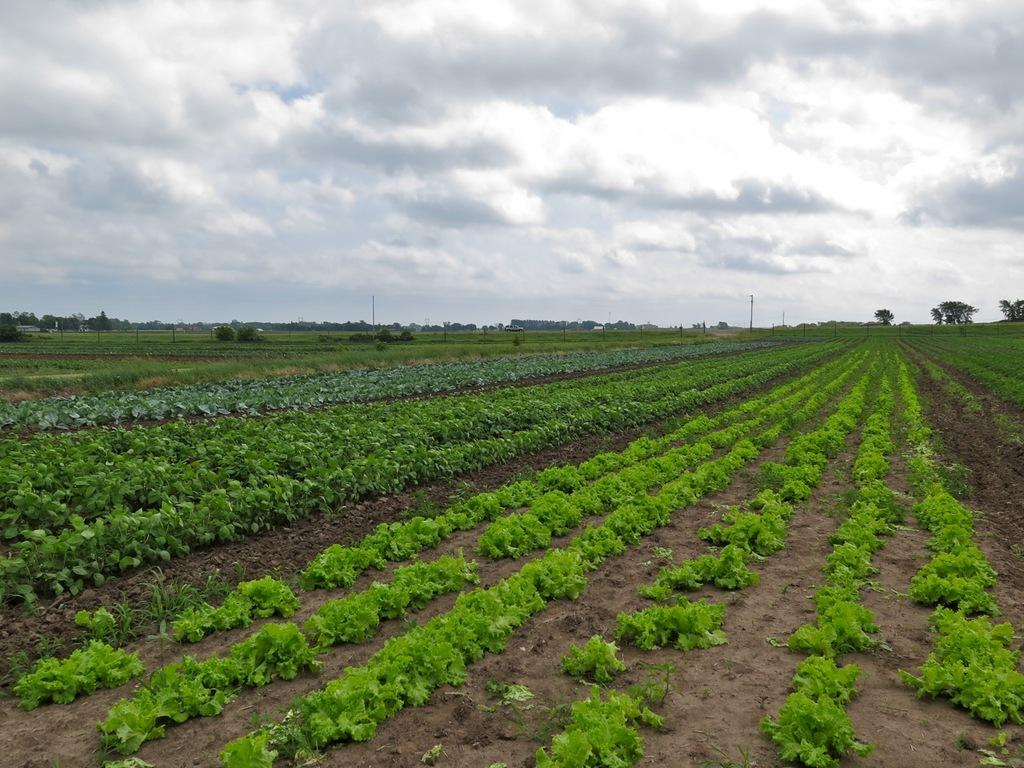What is the main subject in the foreground of the picture? There is a field in the foreground of the picture. What can be found in the field? The field contains plants and soil. What is visible in the background of the picture? There are trees and poles in the background of the picture. How far does the field extend in the image? The field extends into the background. What is visible at the top of the image? There are clouds visible at the top of the image. What type of bomb can be seen in the image? There is no bomb present in the image; it features a field with plants, soil, trees, poles, and clouds. 